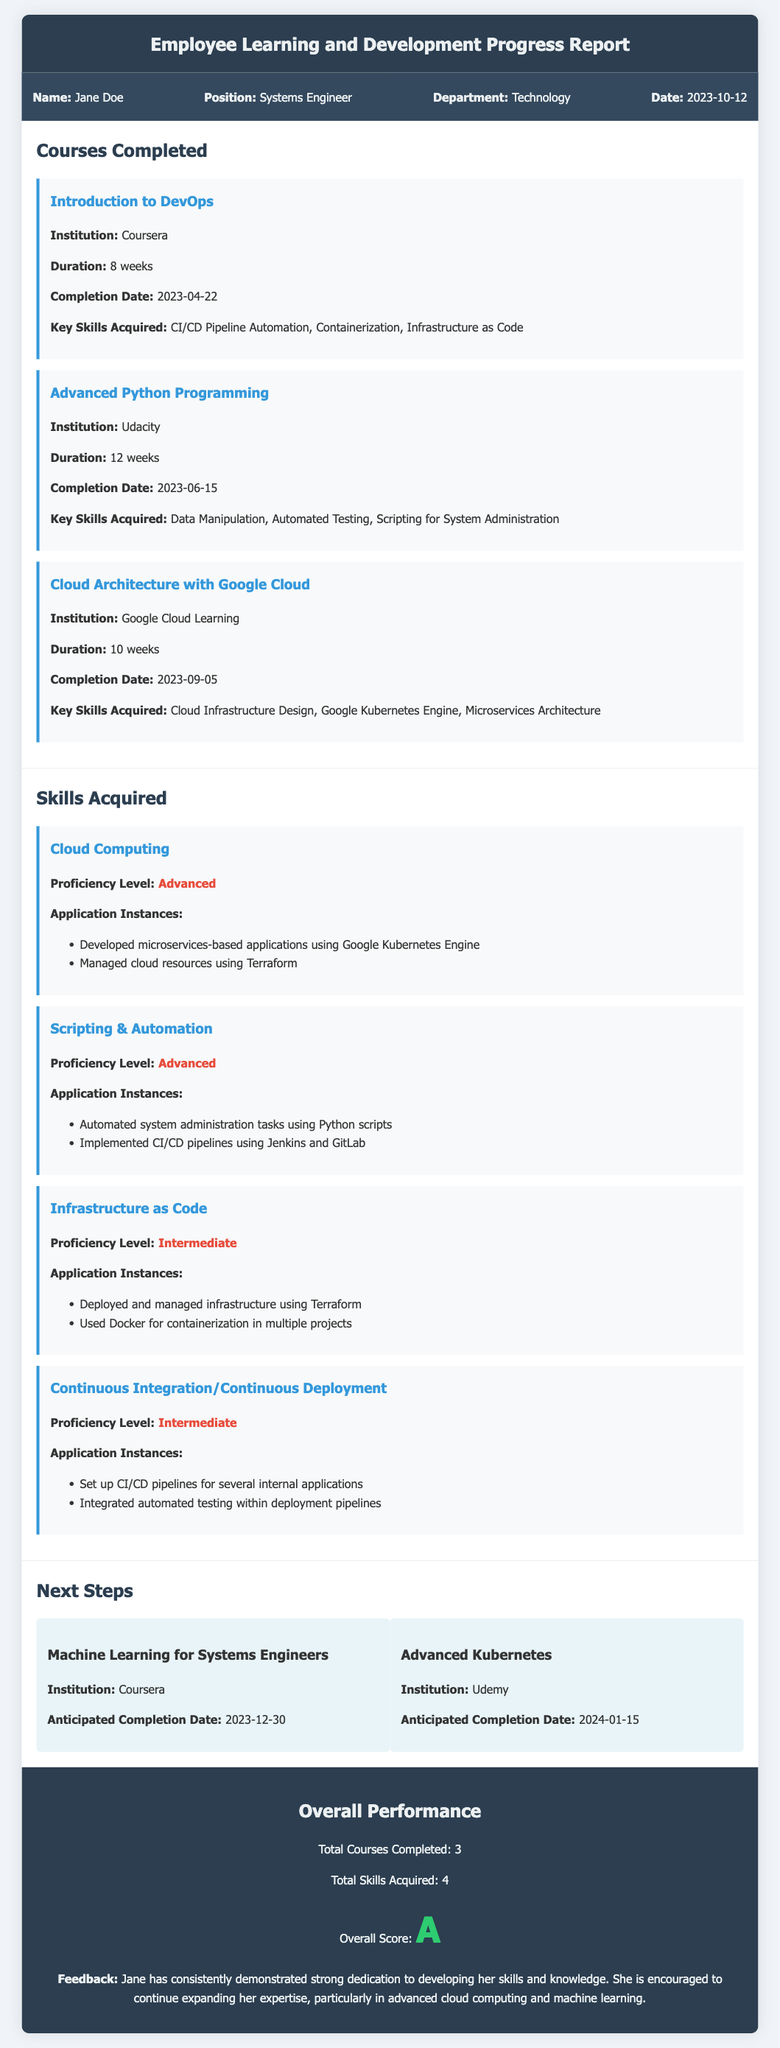What is the employee's name? The document provides the employee's name in the employee information section, which is listed as Jane Doe.
Answer: Jane Doe How many courses has Jane completed? The overall performance section states the total courses completed by Jane, which is three.
Answer: 3 What is the proficiency level of Cloud Computing? The section on Skills Acquired details the proficiency level of Cloud Computing as advanced.
Answer: Advanced When did Jane complete the Cloud Architecture with Google Cloud course? The completion date of the Cloud Architecture course is stated in the courses completed section, which is September 5, 2023.
Answer: 2023-09-05 What skills were acquired in the Introduction to DevOps course? The key skills from the Introduction to DevOps course are listed in the courses completed section as CI/CD Pipeline Automation, Containerization, and Infrastructure as Code.
Answer: CI/CD Pipeline Automation, Containerization, Infrastructure as Code What is the anticipated completion date for the Advanced Kubernetes course? The anticipated completion date for the Advanced Kubernetes course is given in the next steps section as January 15, 2024.
Answer: 2024-01-15 How many total skills did Jane acquire? The overall performance section indicates that Jane has acquired a total of four skills.
Answer: 4 What feedback is provided for Jane's overall performance? The document includes feedback stating that Jane has demonstrated strong dedication to developing her skills and knowledge and encourages her to continue expanding her expertise.
Answer: Strong dedication to developing her skills and knowledge 